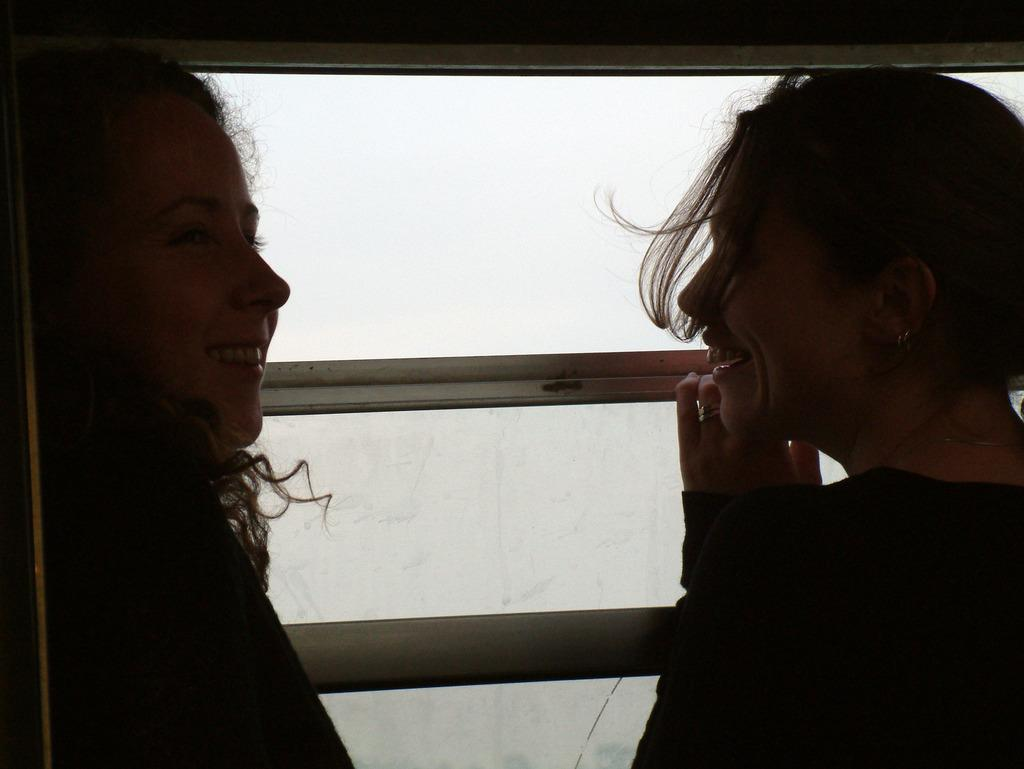How many people are in the image? There are two women in the image. What are the women doing in the image? The women are standing near a window. What expression do the women have in the image? The women are smiling. What type of silver worm can be seen crawling on the window in the image? There is no silver worm present in the image. 